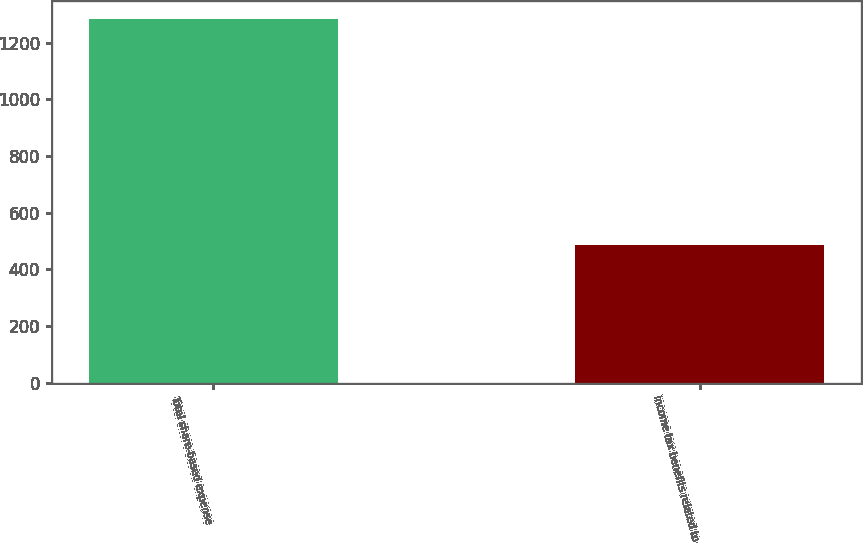Convert chart. <chart><loc_0><loc_0><loc_500><loc_500><bar_chart><fcel>Total share-based expense<fcel>Income tax benefits related to<nl><fcel>1282<fcel>487<nl></chart> 